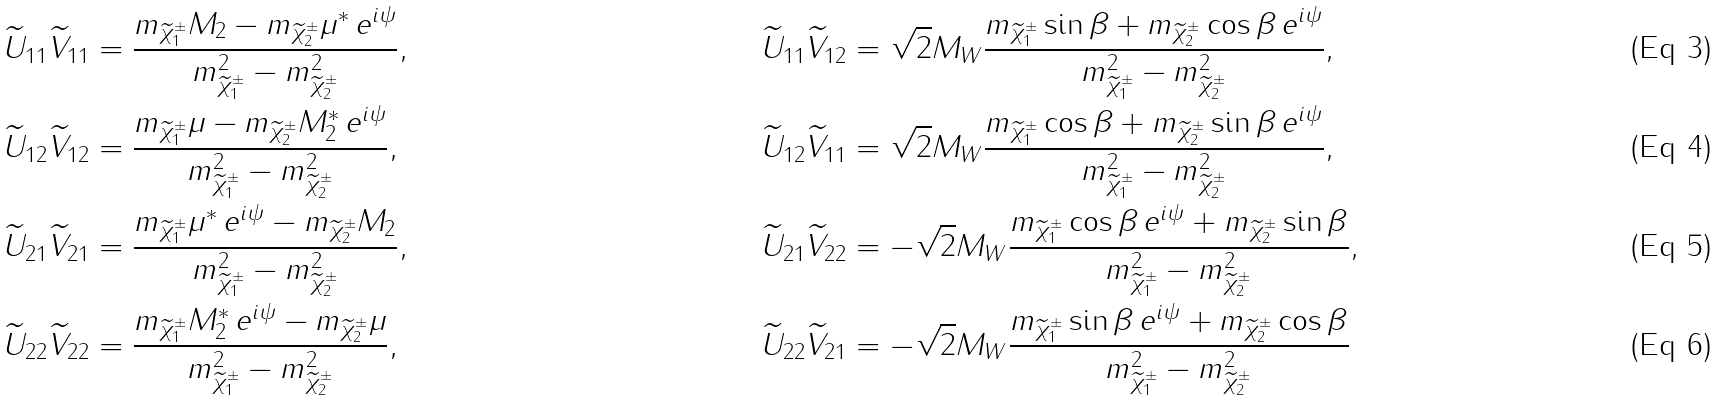Convert formula to latex. <formula><loc_0><loc_0><loc_500><loc_500>\widetilde { U } _ { 1 1 } \widetilde { V } _ { 1 1 } & = \frac { m _ { \widetilde { \chi } _ { 1 } ^ { \pm } } M _ { 2 } - m _ { \widetilde { \chi } _ { 2 } ^ { \pm } } \mu ^ { * } \, e ^ { i \psi } } { m _ { \widetilde { \chi } _ { 1 } ^ { \pm } } ^ { 2 } - m _ { \widetilde { \chi } _ { 2 } ^ { \pm } } ^ { 2 } } , & \widetilde { U } _ { 1 1 } \widetilde { V } _ { 1 2 } & = \sqrt { 2 } M _ { W } \frac { m _ { \widetilde { \chi } _ { 1 } ^ { \pm } } \sin \beta + m _ { \widetilde { \chi } _ { 2 } ^ { \pm } } \cos \beta \, e ^ { i \psi } } { m _ { \widetilde { \chi } _ { 1 } ^ { \pm } } ^ { 2 } - m _ { \widetilde { \chi } _ { 2 } ^ { \pm } } ^ { 2 } } , \\ \widetilde { U } _ { 1 2 } \widetilde { V } _ { 1 2 } & = \frac { m _ { \widetilde { \chi } _ { 1 } ^ { \pm } } \mu - m _ { \widetilde { \chi } _ { 2 } ^ { \pm } } M _ { 2 } ^ { * } \, e ^ { i \psi } } { m _ { \widetilde { \chi } _ { 1 } ^ { \pm } } ^ { 2 } - m _ { \widetilde { \chi } _ { 2 } ^ { \pm } } ^ { 2 } } , & \widetilde { U } _ { 1 2 } \widetilde { V } _ { 1 1 } & = \sqrt { 2 } M _ { W } \frac { m _ { \widetilde { \chi } _ { 1 } ^ { \pm } } \cos \beta + m _ { \widetilde { \chi } _ { 2 } ^ { \pm } } \sin \beta \, e ^ { i \psi } } { m _ { \widetilde { \chi } _ { 1 } ^ { \pm } } ^ { 2 } - m _ { \widetilde { \chi } _ { 2 } ^ { \pm } } ^ { 2 } } , \\ \widetilde { U } _ { 2 1 } \widetilde { V } _ { 2 1 } & = \frac { m _ { \widetilde { \chi } _ { 1 } ^ { \pm } } \mu ^ { * } \, e ^ { i \psi } - m _ { \widetilde { \chi } _ { 2 } ^ { \pm } } M _ { 2 } } { m _ { \widetilde { \chi } _ { 1 } ^ { \pm } } ^ { 2 } - m _ { \widetilde { \chi } _ { 2 } ^ { \pm } } ^ { 2 } } , & \widetilde { U } _ { 2 1 } \widetilde { V } _ { 2 2 } & = - \sqrt { 2 } M _ { W } \frac { m _ { \widetilde { \chi } _ { 1 } ^ { \pm } } \cos \beta \, e ^ { i \psi } + m _ { \widetilde { \chi } _ { 2 } ^ { \pm } } \sin \beta } { m _ { \widetilde { \chi } _ { 1 } ^ { \pm } } ^ { 2 } - m _ { \widetilde { \chi } _ { 2 } ^ { \pm } } ^ { 2 } } , \\ \widetilde { U } _ { 2 2 } \widetilde { V } _ { 2 2 } & = \frac { m _ { \widetilde { \chi } _ { 1 } ^ { \pm } } M _ { 2 } ^ { * } \, e ^ { i \psi } - m _ { \widetilde { \chi } _ { 2 } ^ { \pm } } \mu } { m _ { \widetilde { \chi } _ { 1 } ^ { \pm } } ^ { 2 } - m _ { \widetilde { \chi } _ { 2 } ^ { \pm } } ^ { 2 } } , & \widetilde { U } _ { 2 2 } \widetilde { V } _ { 2 1 } & = - \sqrt { 2 } M _ { W } \frac { m _ { \widetilde { \chi } _ { 1 } ^ { \pm } } \sin \beta \, e ^ { i \psi } + m _ { \widetilde { \chi } _ { 2 } ^ { \pm } } \cos \beta } { m _ { \widetilde { \chi } _ { 1 } ^ { \pm } } ^ { 2 } - m _ { \widetilde { \chi } _ { 2 } ^ { \pm } } ^ { 2 } }</formula> 